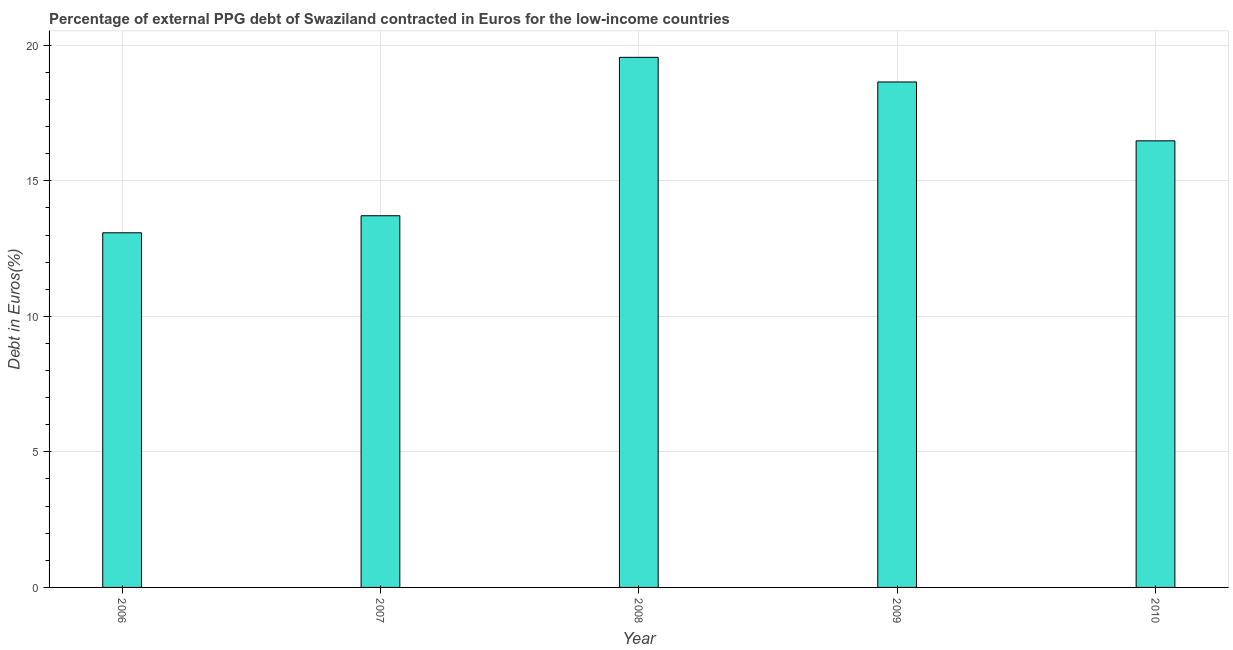What is the title of the graph?
Your response must be concise. Percentage of external PPG debt of Swaziland contracted in Euros for the low-income countries. What is the label or title of the X-axis?
Keep it short and to the point. Year. What is the label or title of the Y-axis?
Offer a terse response. Debt in Euros(%). What is the currency composition of ppg debt in 2010?
Your answer should be compact. 16.47. Across all years, what is the maximum currency composition of ppg debt?
Provide a short and direct response. 19.55. Across all years, what is the minimum currency composition of ppg debt?
Keep it short and to the point. 13.08. In which year was the currency composition of ppg debt maximum?
Your answer should be very brief. 2008. In which year was the currency composition of ppg debt minimum?
Your answer should be very brief. 2006. What is the sum of the currency composition of ppg debt?
Give a very brief answer. 81.47. What is the difference between the currency composition of ppg debt in 2006 and 2010?
Keep it short and to the point. -3.39. What is the average currency composition of ppg debt per year?
Your response must be concise. 16.29. What is the median currency composition of ppg debt?
Your answer should be very brief. 16.47. Do a majority of the years between 2008 and 2007 (inclusive) have currency composition of ppg debt greater than 16 %?
Ensure brevity in your answer.  No. What is the ratio of the currency composition of ppg debt in 2007 to that in 2008?
Provide a succinct answer. 0.7. Is the difference between the currency composition of ppg debt in 2009 and 2010 greater than the difference between any two years?
Provide a short and direct response. No. What is the difference between the highest and the second highest currency composition of ppg debt?
Your answer should be very brief. 0.91. What is the difference between the highest and the lowest currency composition of ppg debt?
Your answer should be very brief. 6.47. How many bars are there?
Your answer should be compact. 5. Are all the bars in the graph horizontal?
Your answer should be very brief. No. What is the difference between two consecutive major ticks on the Y-axis?
Your response must be concise. 5. What is the Debt in Euros(%) in 2006?
Give a very brief answer. 13.08. What is the Debt in Euros(%) in 2007?
Ensure brevity in your answer.  13.71. What is the Debt in Euros(%) in 2008?
Provide a succinct answer. 19.55. What is the Debt in Euros(%) in 2009?
Your response must be concise. 18.64. What is the Debt in Euros(%) of 2010?
Offer a very short reply. 16.47. What is the difference between the Debt in Euros(%) in 2006 and 2007?
Ensure brevity in your answer.  -0.63. What is the difference between the Debt in Euros(%) in 2006 and 2008?
Keep it short and to the point. -6.47. What is the difference between the Debt in Euros(%) in 2006 and 2009?
Provide a short and direct response. -5.56. What is the difference between the Debt in Euros(%) in 2006 and 2010?
Make the answer very short. -3.39. What is the difference between the Debt in Euros(%) in 2007 and 2008?
Your answer should be very brief. -5.84. What is the difference between the Debt in Euros(%) in 2007 and 2009?
Your answer should be compact. -4.93. What is the difference between the Debt in Euros(%) in 2007 and 2010?
Offer a terse response. -2.76. What is the difference between the Debt in Euros(%) in 2008 and 2009?
Your answer should be very brief. 0.91. What is the difference between the Debt in Euros(%) in 2008 and 2010?
Your response must be concise. 3.08. What is the difference between the Debt in Euros(%) in 2009 and 2010?
Give a very brief answer. 2.17. What is the ratio of the Debt in Euros(%) in 2006 to that in 2007?
Offer a terse response. 0.95. What is the ratio of the Debt in Euros(%) in 2006 to that in 2008?
Make the answer very short. 0.67. What is the ratio of the Debt in Euros(%) in 2006 to that in 2009?
Give a very brief answer. 0.7. What is the ratio of the Debt in Euros(%) in 2006 to that in 2010?
Keep it short and to the point. 0.79. What is the ratio of the Debt in Euros(%) in 2007 to that in 2008?
Offer a very short reply. 0.7. What is the ratio of the Debt in Euros(%) in 2007 to that in 2009?
Your response must be concise. 0.73. What is the ratio of the Debt in Euros(%) in 2007 to that in 2010?
Give a very brief answer. 0.83. What is the ratio of the Debt in Euros(%) in 2008 to that in 2009?
Your response must be concise. 1.05. What is the ratio of the Debt in Euros(%) in 2008 to that in 2010?
Provide a succinct answer. 1.19. What is the ratio of the Debt in Euros(%) in 2009 to that in 2010?
Your answer should be compact. 1.13. 